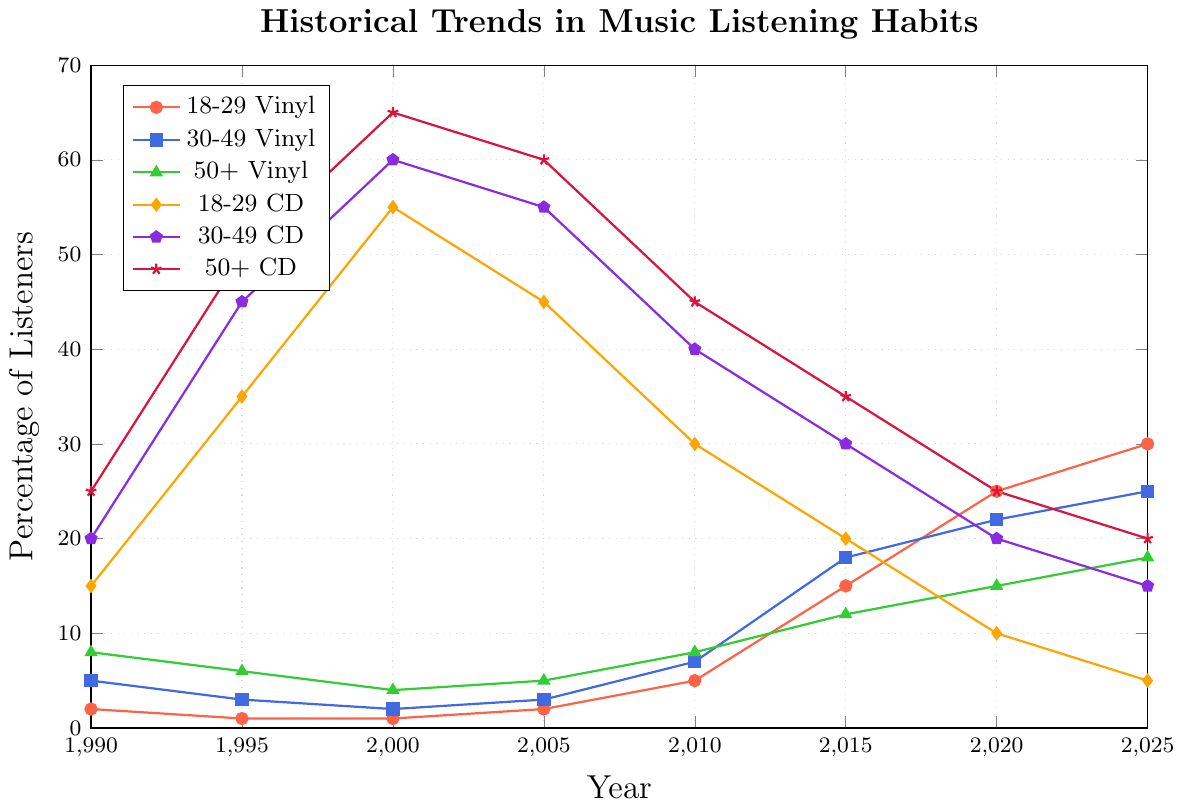What's the trend in vinyl listening habits for the 18-29 age group from 1990 to 2025? Observing the graph, the percentage of 18-29-year-olds listening to vinyl starts at 2% in 1990, slightly dips to 1% in 1995 and 2000, then steadily increases to 30% by 2025.
Answer: Increasing Among the three age groups, who had the highest percentage of CD listeners in 2000? To find the answer, look at the data points for CDs in 2000. The 50+ age group has the highest percentage at 65%.
Answer: 50+ By how much did the percentage of vinyl listeners in the 18-29 age group increase from 1990 to 2025? In 1990, the percentage of vinyl listeners in the 18-29 group was 2%. By 2025, it increased to 30%. So, the increase is 30% - 2% = 28%.
Answer: 28% In which year did the 30-49 age group have equal percentages for vinyl and CD listeners? Looking at the graph, in 2025, both vinyl and CD percentages for the 30-49 age group converge at approximately 25% and 15% respectively. However, in the year(s) provided, no such convergence at the same percentage occurs.
Answer: Never Which age group shows a consistent decrease in CD listening from 2000 to 2025? The 18-29 age group shows a consistent decrease in CD listening, peaking at 55% in 2000 and dropping steadily to 5% by 2025.
Answer: 18-29 What's the average percentage of vinyl listeners in the 30-49 age group over the years provided? To find the average, sum the percentages for the 30-49 vinyl group across years (5+3+2+3+7+18+22+25) and divide by 8. This yields an average of (5+3+2+3+7+18+22+25) / 8 = 10.625%.
Answer: 10.625% How does the percentage of vinyl listeners of the 50+ age group change from 1990 to 2025? The percentage for the 50+ vinyl group starts at 8% in 1990, decreases to 4% by 2000, and then gradually increases to 18% by 2025. So, it shows a dip followed by a rise.
Answer: Decrease then increase In 2010, which age group has a higher percentage of vinyl listeners, the 18-29 or 50+ group? In 2010, the graph shows the 18-29 age group at 5% vinyl listeners and the 50+ group at 8%. Thus, the 50+ group has a higher percentage.
Answer: 50+ Compare the trends of CD listening habits for the 30-49 and 50+ age groups from 2000 to 2025. Both age groups show a consistent decline in CD listening from 2000 to 2025. The 30-49 group drops from 60% to 15%, and the 50+ group drops from 65% to 20%. The percentages remain higher for the 50+ group throughout this period.
Answer: Declining for both 